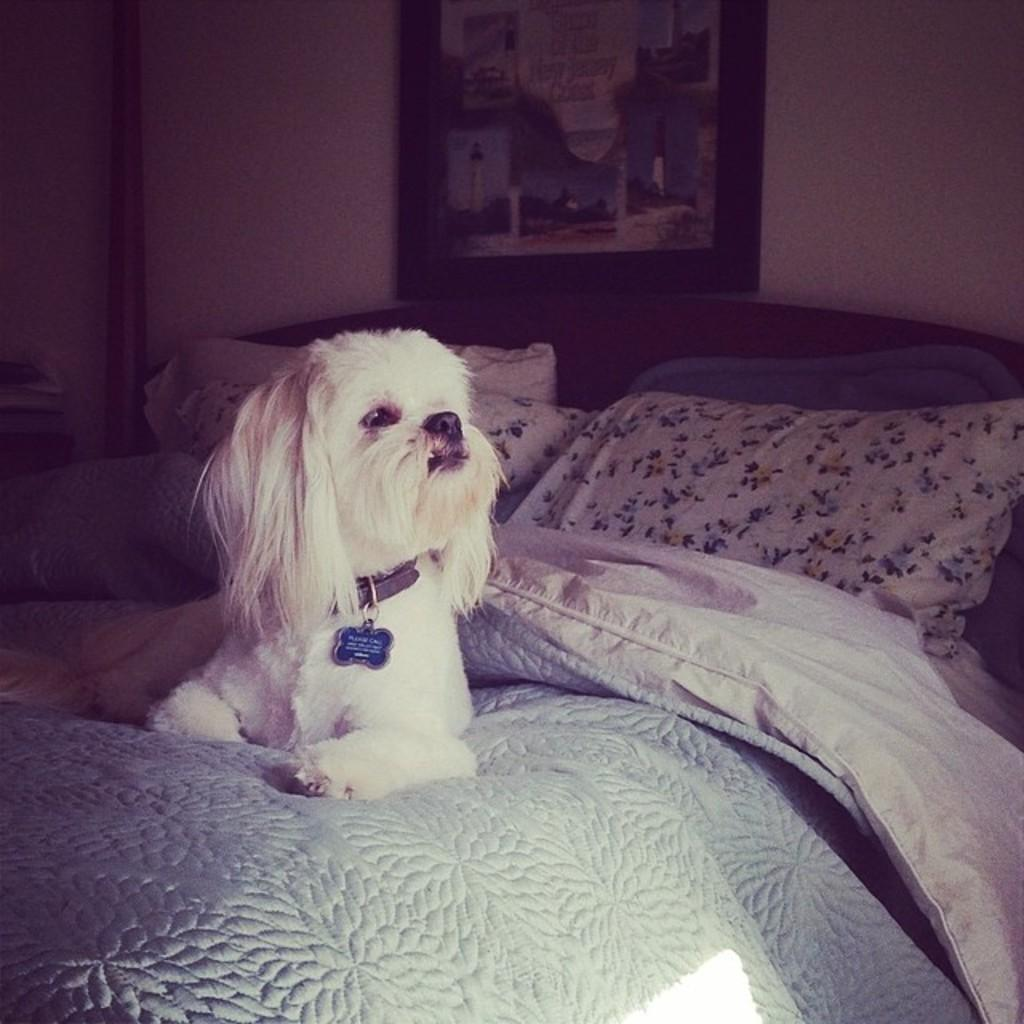What type of animal is in the image? There is a dog in the image. Where is the dog located in the image? The dog is sitting in a bed. What else can be seen in the bed with the dog? There is a blanket in the image. What is also present in the bedding area? There is a pillow in the image. What is attached to the wall in the image? There is a frame attached to the wall in the image. How many family members are present in the image? There is no reference to family members in the image; it only features a dog, a bed, a blanket, a pillow, and a frame on the wall. 